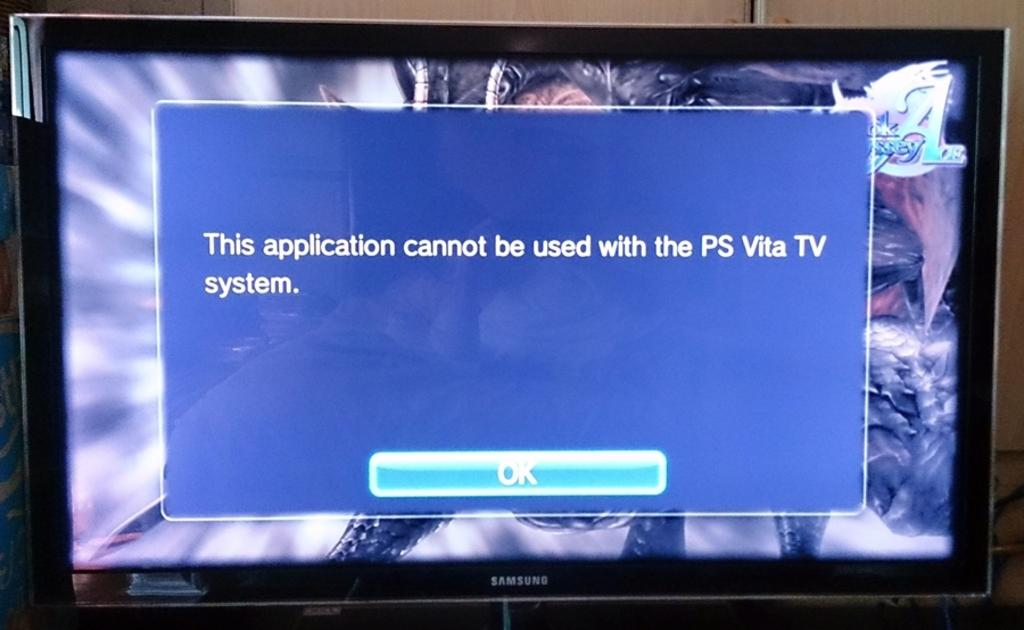Provide a one-sentence caption for the provided image. an error on the tv reading : application cannot be used with the PS Vita TV system. 